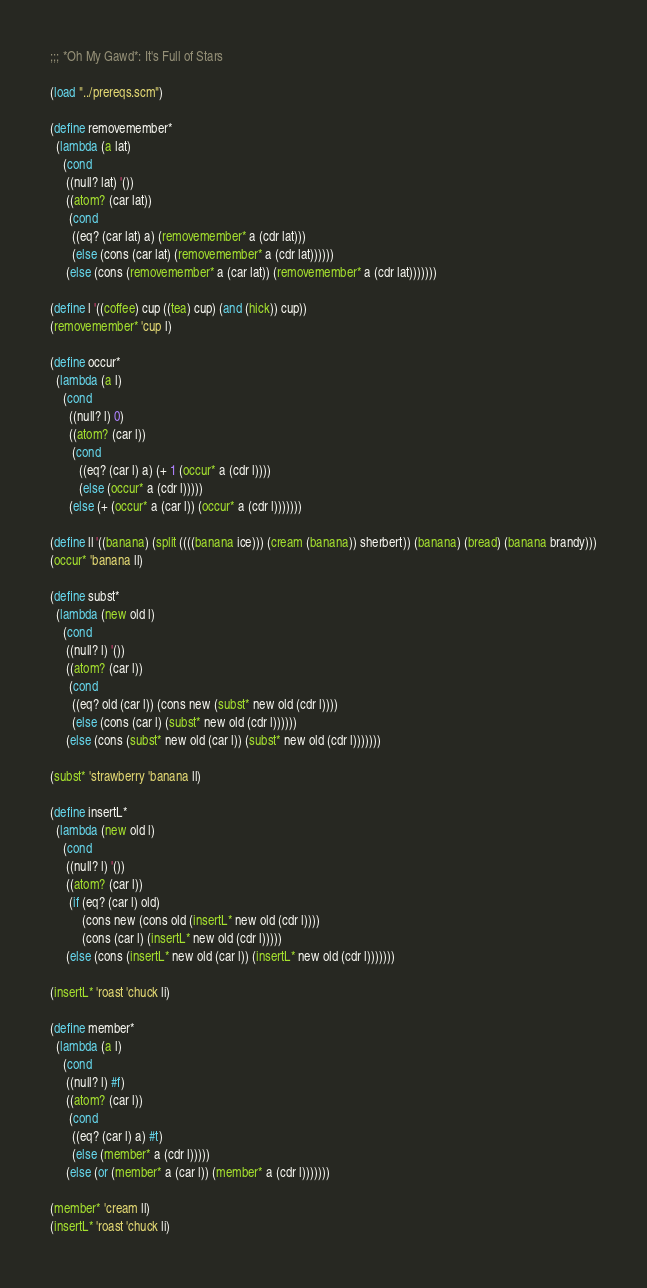Convert code to text. <code><loc_0><loc_0><loc_500><loc_500><_Scheme_>;;; *Oh My Gawd*: It's Full of Stars

(load "../prereqs.scm")

(define removemember*
  (lambda (a lat)
    (cond
     ((null? lat) '())
     ((atom? (car lat))
      (cond
       ((eq? (car lat) a) (removemember* a (cdr lat)))
       (else (cons (car lat) (removemember* a (cdr lat))))))
     (else (cons (removemember* a (car lat)) (removemember* a (cdr lat)))))))

(define l '((coffee) cup ((tea) cup) (and (hick)) cup))
(removemember* 'cup l)

(define occur*
  (lambda (a l)
    (cond 
      ((null? l) 0)
      ((atom? (car l))
       (cond 
         ((eq? (car l) a) (+ 1 (occur* a (cdr l))))
         (else (occur* a (cdr l)))))
      (else (+ (occur* a (car l)) (occur* a (cdr l)))))))

(define ll '((banana) (split ((((banana ice))) (cream (banana)) sherbert)) (banana) (bread) (banana brandy)))
(occur* 'banana ll)

(define subst*
  (lambda (new old l)
    (cond
     ((null? l) '())
     ((atom? (car l))
      (cond
       ((eq? old (car l)) (cons new (subst* new old (cdr l))))
       (else (cons (car l) (subst* new old (cdr l))))))
     (else (cons (subst* new old (car l)) (subst* new old (cdr l)))))))

(subst* 'strawberry 'banana ll)

(define insertL*
  (lambda (new old l)
    (cond
     ((null? l) '())
     ((atom? (car l))
      (if (eq? (car l) old)
          (cons new (cons old (insertL* new old (cdr l))))
          (cons (car l) (insertL* new old (cdr l)))))
     (else (cons (insertL* new old (car l)) (insertL* new old (cdr l)))))))

(insertL* 'roast 'chuck li)

(define member*
  (lambda (a l)
    (cond
     ((null? l) #f)
     ((atom? (car l))
      (cond
       ((eq? (car l) a) #t)
       (else (member* a (cdr l)))))
     (else (or (member* a (car l)) (member* a (cdr l)))))))

(member* 'cream ll)
(insertL* 'roast 'chuck li)
</code> 